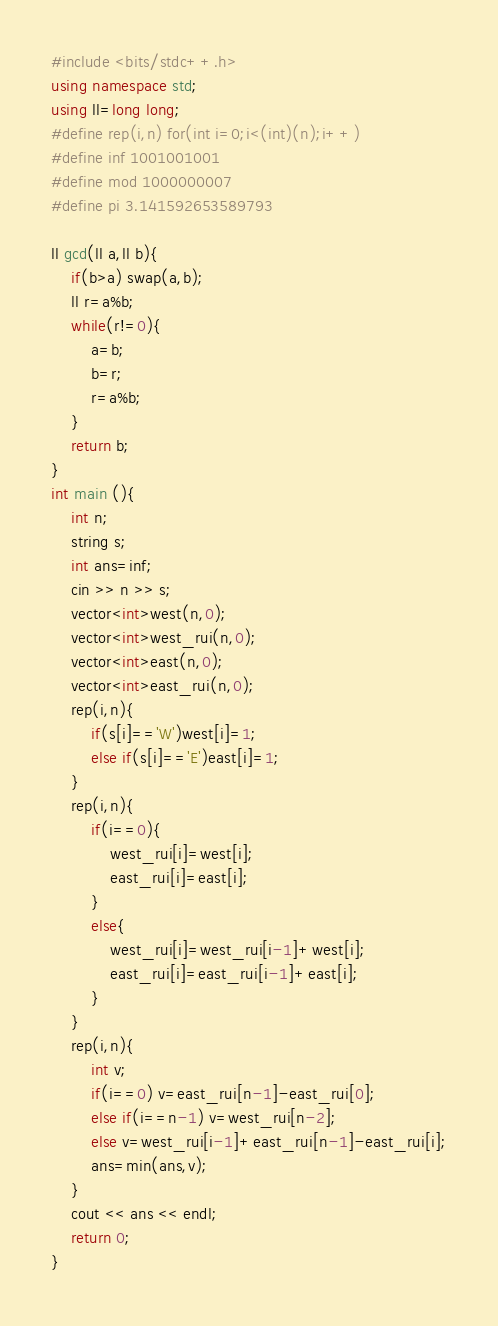<code> <loc_0><loc_0><loc_500><loc_500><_C++_>#include <bits/stdc++.h>
using namespace std;
using ll=long long;
#define rep(i,n) for(int i=0;i<(int)(n);i++)
#define inf 1001001001
#define mod 1000000007
#define pi 3.141592653589793

ll gcd(ll a,ll b){
    if(b>a) swap(a,b);
    ll r=a%b;
    while(r!=0){
        a=b;
        b=r;
        r=a%b;
    }
    return b;
}
int main (){
    int n;
    string s;
    int ans=inf;
    cin >> n >> s;
    vector<int>west(n,0);
    vector<int>west_rui(n,0);
    vector<int>east(n,0);
    vector<int>east_rui(n,0);
    rep(i,n){
        if(s[i]=='W')west[i]=1;
        else if(s[i]=='E')east[i]=1;
    }
    rep(i,n){
        if(i==0){
            west_rui[i]=west[i];
            east_rui[i]=east[i];
        }
        else{
            west_rui[i]=west_rui[i-1]+west[i];
            east_rui[i]=east_rui[i-1]+east[i];
        }
    }
    rep(i,n){
        int v;
        if(i==0) v=east_rui[n-1]-east_rui[0];
        else if(i==n-1) v=west_rui[n-2];
        else v=west_rui[i-1]+east_rui[n-1]-east_rui[i];
        ans=min(ans,v);
    }
    cout << ans << endl;
    return 0;
}

</code> 